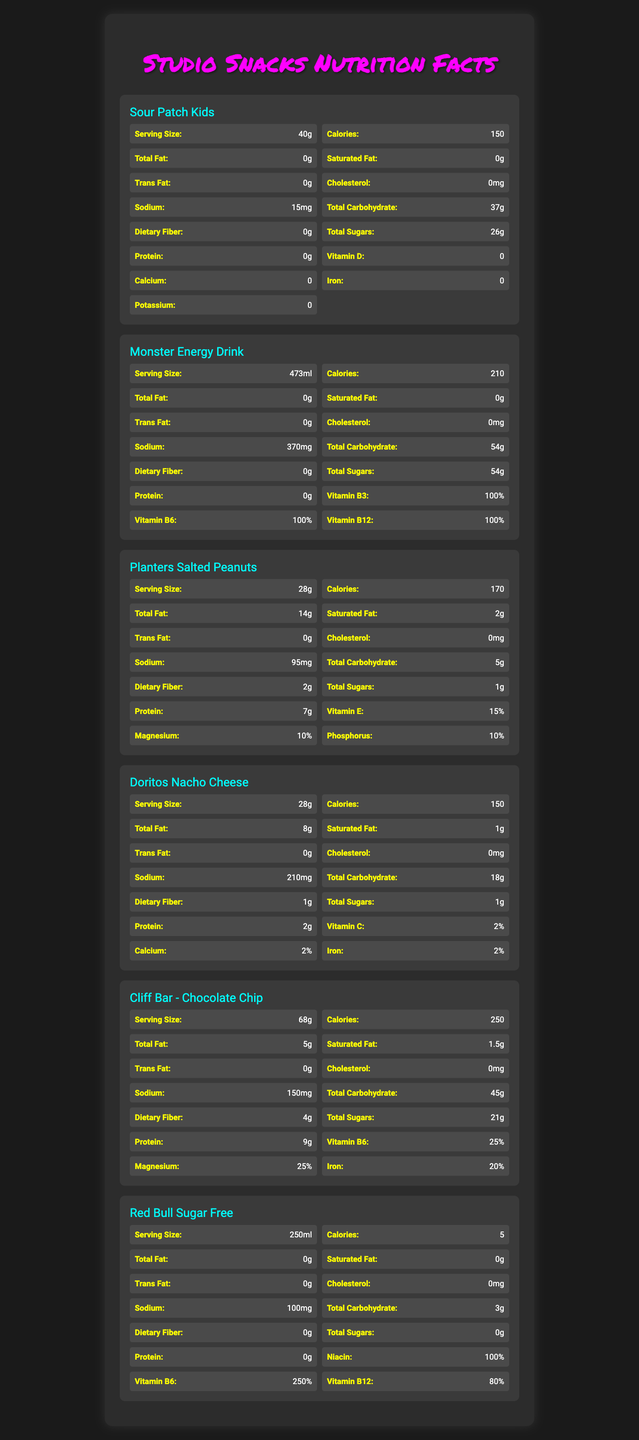what is the serving size of Sour Patch Kids? The document states that the serving size of Sour Patch Kids is 40g.
Answer: 40g how many calories are in a serving of Monster Energy Drink? The nutrition facts for Monster Energy Drink indicate that it contains 210 calories per serving.
Answer: 210 what is the total fat content in a serving of Planters Salted Peanuts? The total fat content in a serving of Planters Salted Peanuts is 14g, as stated in the document.
Answer: 14g how much protein does a Cliff Bar - Chocolate Chip contain? The document lists that a Cliff Bar - Chocolate Chip contains 9g of protein per serving.
Answer: 9g what is the sodium content in a serving of Doritos Nacho Cheese? The sodium content for Doritos Nacho Cheese is 210mg per serving according to the document.
Answer: 210mg which food has the highest carbohydrate content? A. Sour Patch Kids B. Monster Energy Drink C. Doritos Nacho Cheese D. Cliff Bar - Chocolate Chip Monster Energy Drink has the highest carbohydrate content with 54g per serving.
Answer: B. Monster Energy Drink which of the following items has sodium level closest to zero? 1. Sour Patch Kids 2. Monster Energy Drink 3. Planters Salted Peanuts 4. Red Bull Sugar Free Sour Patch Kids has the sodium level closest to zero, with only 15mg per serving.
Answer: 1. Sour Patch Kids is there any cholesterol in Doritos Nacho Cheese? According to the document, Doritos Nacho Cheese contains 0mg of cholesterol per serving.
Answer: No summarize the nutrition facts for the snacks and drinks listed in the document. The document presents comprehensive nutritional data for six snacks and drinks, detailing their caloric and macronutrient profiles, as well as other nutritional contents like vitamins and minerals.
Answer: The document provides nutritional information for six products commonly found in recording studio vending machines: Sour Patch Kids, Monster Energy Drink, Planters Salted Peanuts, Doritos Nacho Cheese, Cliff Bar - Chocolate Chip, and Red Bull Sugar Free. The key details include serving size, calories, total fat, saturated fat, trans fat, cholesterol, sodium, total carbohydrate, dietary fiber, total sugars, protein, and vitamins/minerals percentages. Each product has varying amounts of these nutrients, with some items being higher in sugars and carbohydrates, while others emphasize protein or specific vitamins. what is the magnesium content in Sour Patch Kids? The document does not provide information about the magnesium content in Sour Patch Kids.
Answer: Cannot be determined what percentage of Vitamin B6 is in Monster Energy Drink? Monster Energy Drink contains 100% of the daily value for Vitamin B6 per serving as noted in the document.
Answer: 100% 